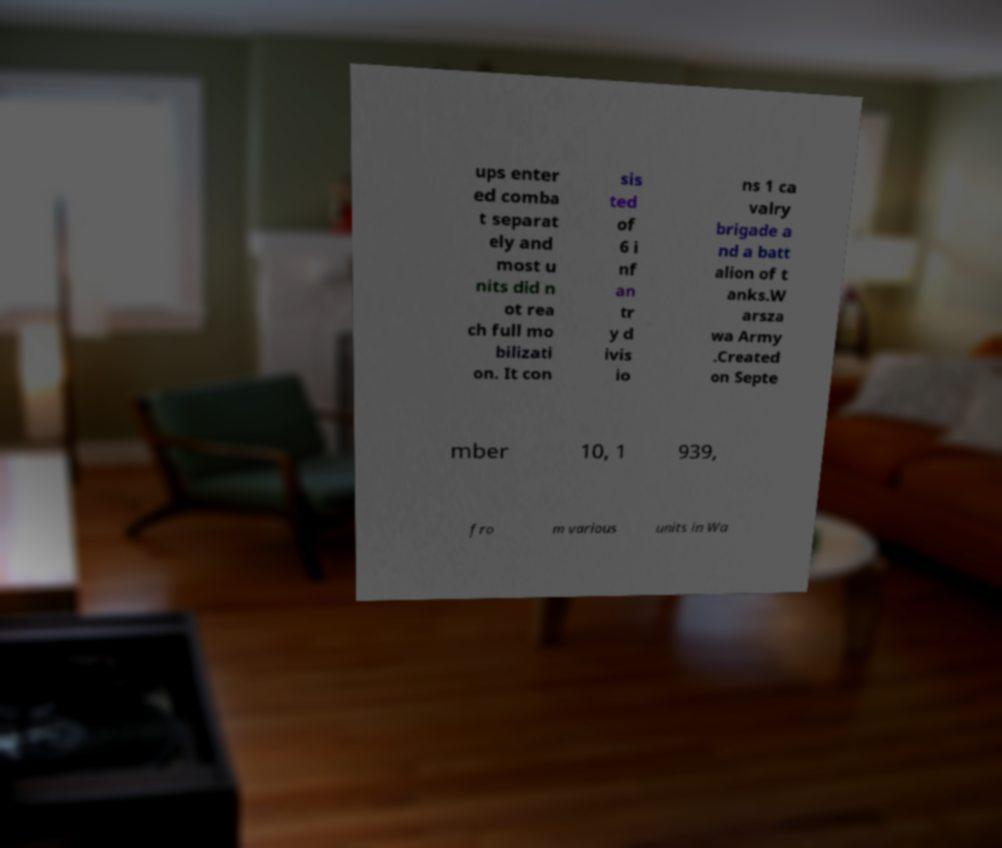Could you assist in decoding the text presented in this image and type it out clearly? ups enter ed comba t separat ely and most u nits did n ot rea ch full mo bilizati on. It con sis ted of 6 i nf an tr y d ivis io ns 1 ca valry brigade a nd a batt alion of t anks.W arsza wa Army .Created on Septe mber 10, 1 939, fro m various units in Wa 